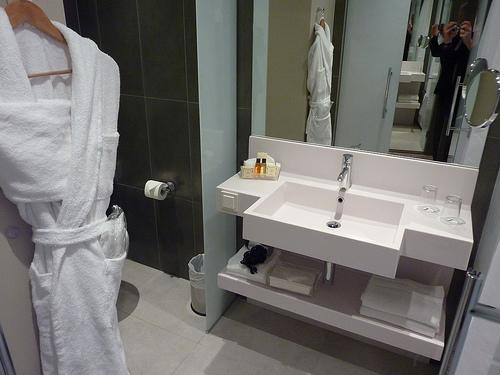What textile objects are visible in the image and in what condition are they? A white robe and bath towels, both appearing clean, fluffy, and neatly arranged. Mention the objects that can be found on the counter in the image. Two clear drinking glasses, a basket with shampoo and conditioner, and two cups on the counter. Point out some details about the reflections in the large mirror. A reflection of a person taking a picture, a camera, and a white bathrobe hanging on the wall. Describe the hanging object in the image and its purpose. A fluffy white robe on a wooden hanger, providing comfort and warmth after a bath or shower. Briefly mention the most notable objects in the image. A white robe, large mirror, towels, roll of toilet paper, two glasses, a trash can, and a person taking a picture in the reflection. Describe the most interesting object in the image and what makes it interesting. A large white bathroom sink with a sleek chrome faucet, due to its modern design and multi-leveled appearance. What elements of the image indicate that the bathroom is being photographed? A reflection of a person taking a picture and a camera in the large mirror. Mention three objects in the image that are related to personal hygiene. A roll of toilet paper, white folded towels, and a basket with shampoo and conditioner. Provide a summary of the bathroom scene in the image. A tidy restroom with a white robe, folded towels, a large mirror, rolled toilet paper, and two empty glasses on a clean counter. Mention an object in the image that is used for waste disposal. A small trash can with a plastic liner for convenient and sanitary waste disposal. 